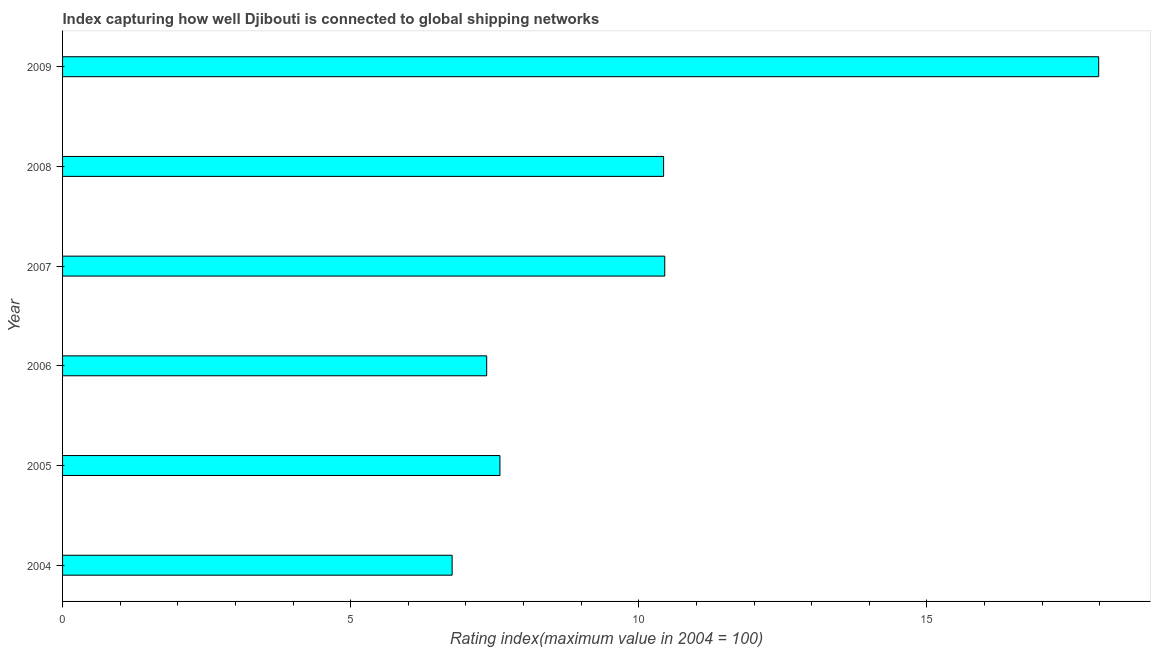Does the graph contain grids?
Offer a very short reply. No. What is the title of the graph?
Your response must be concise. Index capturing how well Djibouti is connected to global shipping networks. What is the label or title of the X-axis?
Your answer should be very brief. Rating index(maximum value in 2004 = 100). What is the liner shipping connectivity index in 2009?
Offer a very short reply. 17.98. Across all years, what is the maximum liner shipping connectivity index?
Keep it short and to the point. 17.98. Across all years, what is the minimum liner shipping connectivity index?
Offer a terse response. 6.76. In which year was the liner shipping connectivity index minimum?
Give a very brief answer. 2004. What is the sum of the liner shipping connectivity index?
Keep it short and to the point. 60.57. What is the difference between the liner shipping connectivity index in 2006 and 2009?
Your response must be concise. -10.62. What is the average liner shipping connectivity index per year?
Make the answer very short. 10.1. What is the median liner shipping connectivity index?
Offer a very short reply. 9.01. In how many years, is the liner shipping connectivity index greater than 5 ?
Offer a very short reply. 6. Do a majority of the years between 2009 and 2005 (inclusive) have liner shipping connectivity index greater than 12 ?
Ensure brevity in your answer.  Yes. What is the ratio of the liner shipping connectivity index in 2006 to that in 2008?
Offer a terse response. 0.71. Is the difference between the liner shipping connectivity index in 2007 and 2009 greater than the difference between any two years?
Your response must be concise. No. What is the difference between the highest and the second highest liner shipping connectivity index?
Offer a very short reply. 7.53. Is the sum of the liner shipping connectivity index in 2006 and 2007 greater than the maximum liner shipping connectivity index across all years?
Ensure brevity in your answer.  No. What is the difference between the highest and the lowest liner shipping connectivity index?
Your answer should be very brief. 11.22. Are all the bars in the graph horizontal?
Provide a succinct answer. Yes. What is the Rating index(maximum value in 2004 = 100) in 2004?
Keep it short and to the point. 6.76. What is the Rating index(maximum value in 2004 = 100) in 2005?
Your answer should be very brief. 7.59. What is the Rating index(maximum value in 2004 = 100) in 2006?
Provide a short and direct response. 7.36. What is the Rating index(maximum value in 2004 = 100) in 2007?
Offer a very short reply. 10.45. What is the Rating index(maximum value in 2004 = 100) in 2008?
Make the answer very short. 10.43. What is the Rating index(maximum value in 2004 = 100) in 2009?
Your response must be concise. 17.98. What is the difference between the Rating index(maximum value in 2004 = 100) in 2004 and 2005?
Your response must be concise. -0.83. What is the difference between the Rating index(maximum value in 2004 = 100) in 2004 and 2007?
Keep it short and to the point. -3.69. What is the difference between the Rating index(maximum value in 2004 = 100) in 2004 and 2008?
Your answer should be compact. -3.67. What is the difference between the Rating index(maximum value in 2004 = 100) in 2004 and 2009?
Provide a short and direct response. -11.22. What is the difference between the Rating index(maximum value in 2004 = 100) in 2005 and 2006?
Keep it short and to the point. 0.23. What is the difference between the Rating index(maximum value in 2004 = 100) in 2005 and 2007?
Your response must be concise. -2.86. What is the difference between the Rating index(maximum value in 2004 = 100) in 2005 and 2008?
Ensure brevity in your answer.  -2.84. What is the difference between the Rating index(maximum value in 2004 = 100) in 2005 and 2009?
Your response must be concise. -10.39. What is the difference between the Rating index(maximum value in 2004 = 100) in 2006 and 2007?
Your response must be concise. -3.09. What is the difference between the Rating index(maximum value in 2004 = 100) in 2006 and 2008?
Keep it short and to the point. -3.07. What is the difference between the Rating index(maximum value in 2004 = 100) in 2006 and 2009?
Make the answer very short. -10.62. What is the difference between the Rating index(maximum value in 2004 = 100) in 2007 and 2008?
Offer a very short reply. 0.02. What is the difference between the Rating index(maximum value in 2004 = 100) in 2007 and 2009?
Keep it short and to the point. -7.53. What is the difference between the Rating index(maximum value in 2004 = 100) in 2008 and 2009?
Ensure brevity in your answer.  -7.55. What is the ratio of the Rating index(maximum value in 2004 = 100) in 2004 to that in 2005?
Your response must be concise. 0.89. What is the ratio of the Rating index(maximum value in 2004 = 100) in 2004 to that in 2006?
Your response must be concise. 0.92. What is the ratio of the Rating index(maximum value in 2004 = 100) in 2004 to that in 2007?
Keep it short and to the point. 0.65. What is the ratio of the Rating index(maximum value in 2004 = 100) in 2004 to that in 2008?
Your answer should be very brief. 0.65. What is the ratio of the Rating index(maximum value in 2004 = 100) in 2004 to that in 2009?
Give a very brief answer. 0.38. What is the ratio of the Rating index(maximum value in 2004 = 100) in 2005 to that in 2006?
Your answer should be compact. 1.03. What is the ratio of the Rating index(maximum value in 2004 = 100) in 2005 to that in 2007?
Offer a terse response. 0.73. What is the ratio of the Rating index(maximum value in 2004 = 100) in 2005 to that in 2008?
Offer a very short reply. 0.73. What is the ratio of the Rating index(maximum value in 2004 = 100) in 2005 to that in 2009?
Provide a short and direct response. 0.42. What is the ratio of the Rating index(maximum value in 2004 = 100) in 2006 to that in 2007?
Your answer should be compact. 0.7. What is the ratio of the Rating index(maximum value in 2004 = 100) in 2006 to that in 2008?
Keep it short and to the point. 0.71. What is the ratio of the Rating index(maximum value in 2004 = 100) in 2006 to that in 2009?
Offer a very short reply. 0.41. What is the ratio of the Rating index(maximum value in 2004 = 100) in 2007 to that in 2009?
Offer a terse response. 0.58. What is the ratio of the Rating index(maximum value in 2004 = 100) in 2008 to that in 2009?
Your answer should be compact. 0.58. 